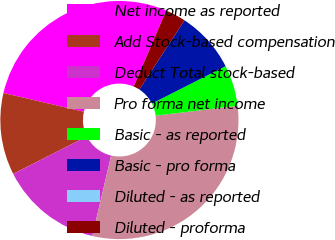<chart> <loc_0><loc_0><loc_500><loc_500><pie_chart><fcel>Net income as reported<fcel>Add Stock-based compensation<fcel>Deduct Total stock-based<fcel>Pro forma net income<fcel>Basic - as reported<fcel>Basic - pro forma<fcel>Diluted - as reported<fcel>Diluted - proforma<nl><fcel>27.78%<fcel>11.11%<fcel>13.89%<fcel>30.56%<fcel>5.56%<fcel>8.33%<fcel>0.0%<fcel>2.78%<nl></chart> 